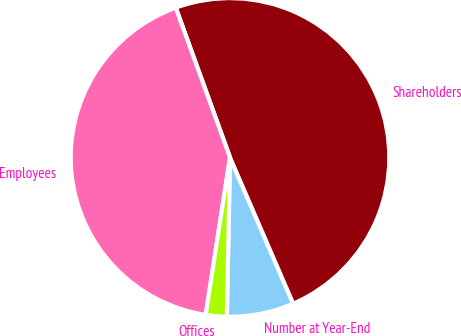Convert chart to OTSL. <chart><loc_0><loc_0><loc_500><loc_500><pie_chart><fcel>Number at Year-End<fcel>Shareholders<fcel>Employees<fcel>Offices<nl><fcel>6.81%<fcel>49.04%<fcel>42.03%<fcel>2.12%<nl></chart> 